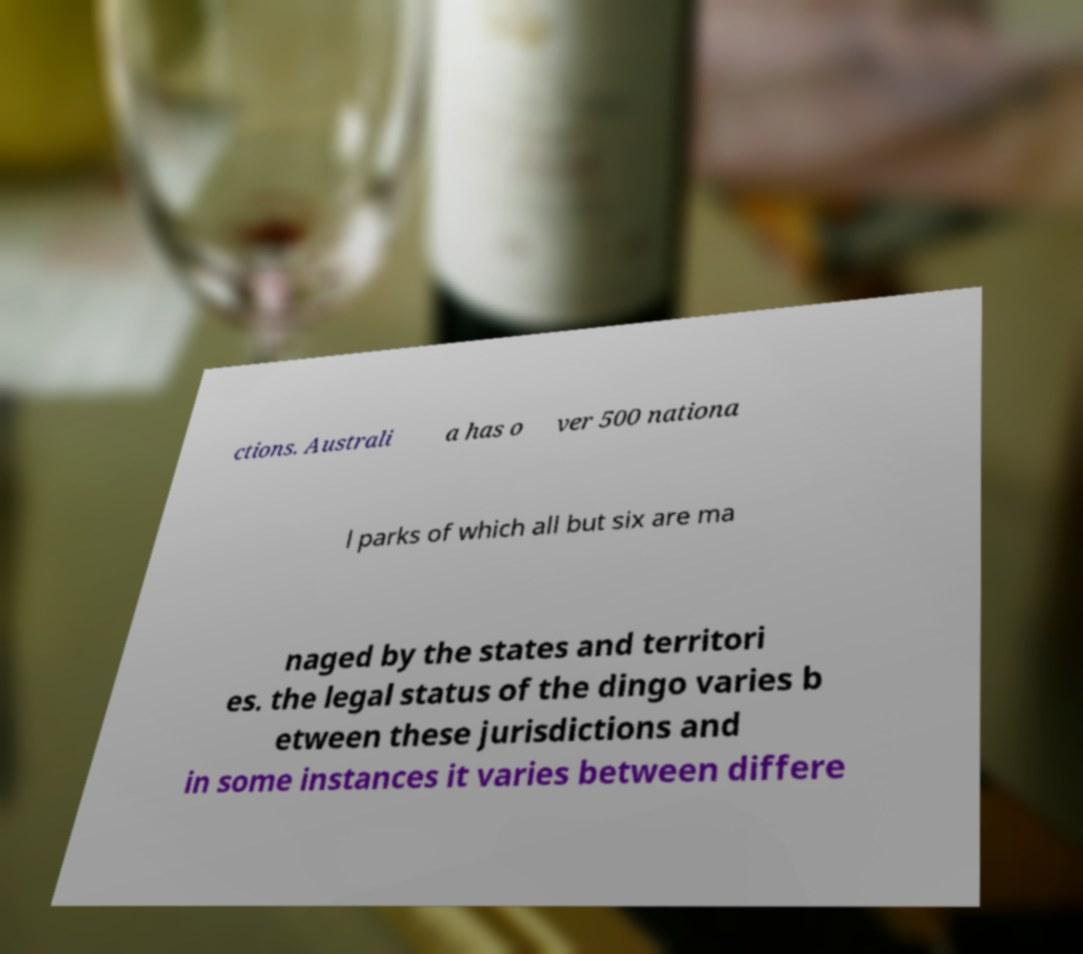Could you extract and type out the text from this image? ctions. Australi a has o ver 500 nationa l parks of which all but six are ma naged by the states and territori es. the legal status of the dingo varies b etween these jurisdictions and in some instances it varies between differe 